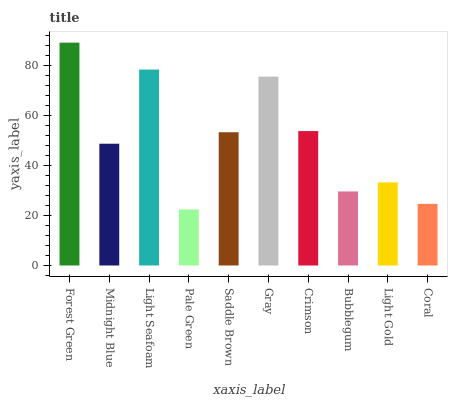Is Pale Green the minimum?
Answer yes or no. Yes. Is Forest Green the maximum?
Answer yes or no. Yes. Is Midnight Blue the minimum?
Answer yes or no. No. Is Midnight Blue the maximum?
Answer yes or no. No. Is Forest Green greater than Midnight Blue?
Answer yes or no. Yes. Is Midnight Blue less than Forest Green?
Answer yes or no. Yes. Is Midnight Blue greater than Forest Green?
Answer yes or no. No. Is Forest Green less than Midnight Blue?
Answer yes or no. No. Is Saddle Brown the high median?
Answer yes or no. Yes. Is Midnight Blue the low median?
Answer yes or no. Yes. Is Bubblegum the high median?
Answer yes or no. No. Is Light Gold the low median?
Answer yes or no. No. 